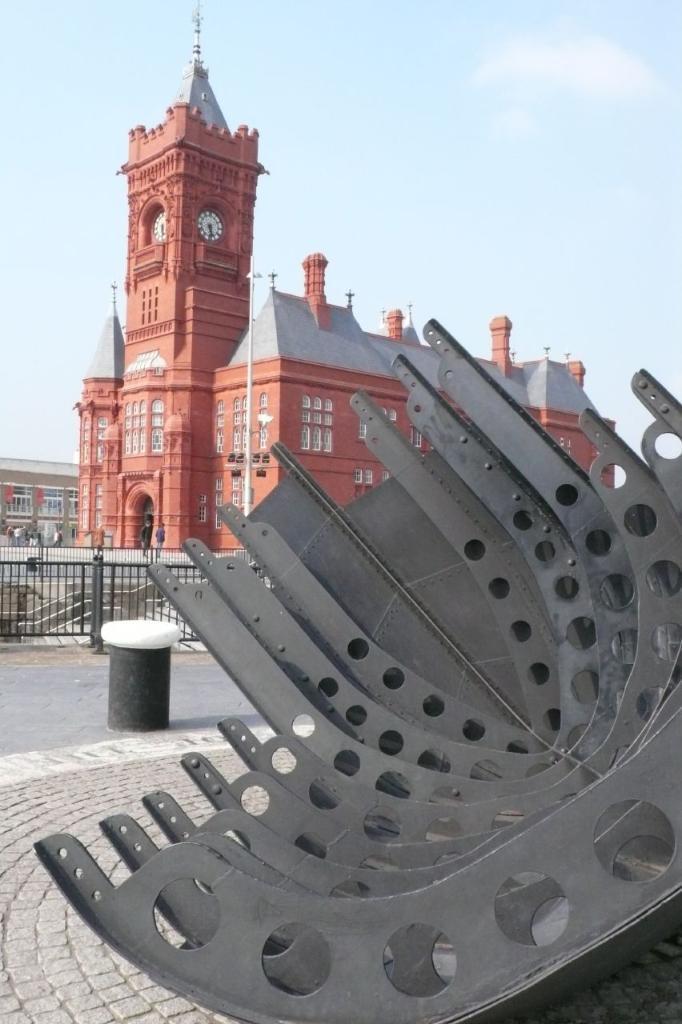Can you describe this image briefly? In the image we can see the building, these are the windows of the building and we can even see a clock. Here we can see a metal object, footpath, road, fence and the sky. We can even see there are people. 